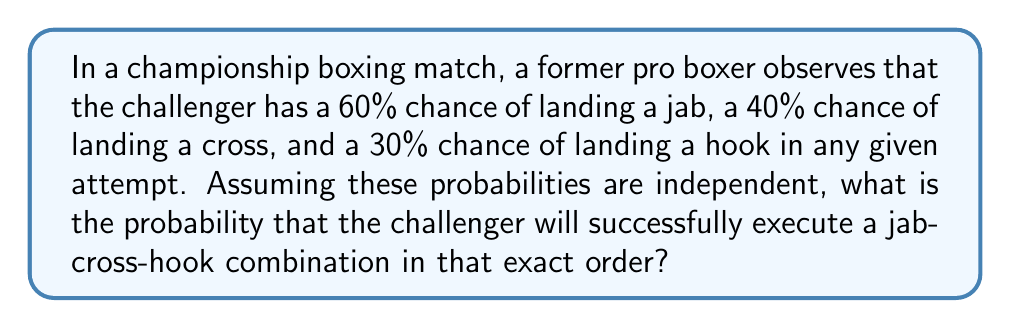Provide a solution to this math problem. Let's approach this step-by-step:

1) We need to calculate the probability of three independent events occurring in succession:
   - Landing a jab (probability = 0.60)
   - Followed by landing a cross (probability = 0.40)
   - Followed by landing a hook (probability = 0.30)

2) When we have independent events occurring in sequence, we multiply their individual probabilities:

   $$P(\text{jab-cross-hook}) = P(\text{jab}) \times P(\text{cross}) \times P(\text{hook})$$

3) Substituting the given probabilities:

   $$P(\text{jab-cross-hook}) = 0.60 \times 0.40 \times 0.30$$

4) Calculating:

   $$P(\text{jab-cross-hook}) = 0.072$$

5) Converting to a percentage:

   $$0.072 \times 100\% = 7.2\%$$

Thus, the probability of the challenger successfully executing this specific combination is 7.2%.
Answer: 7.2% 